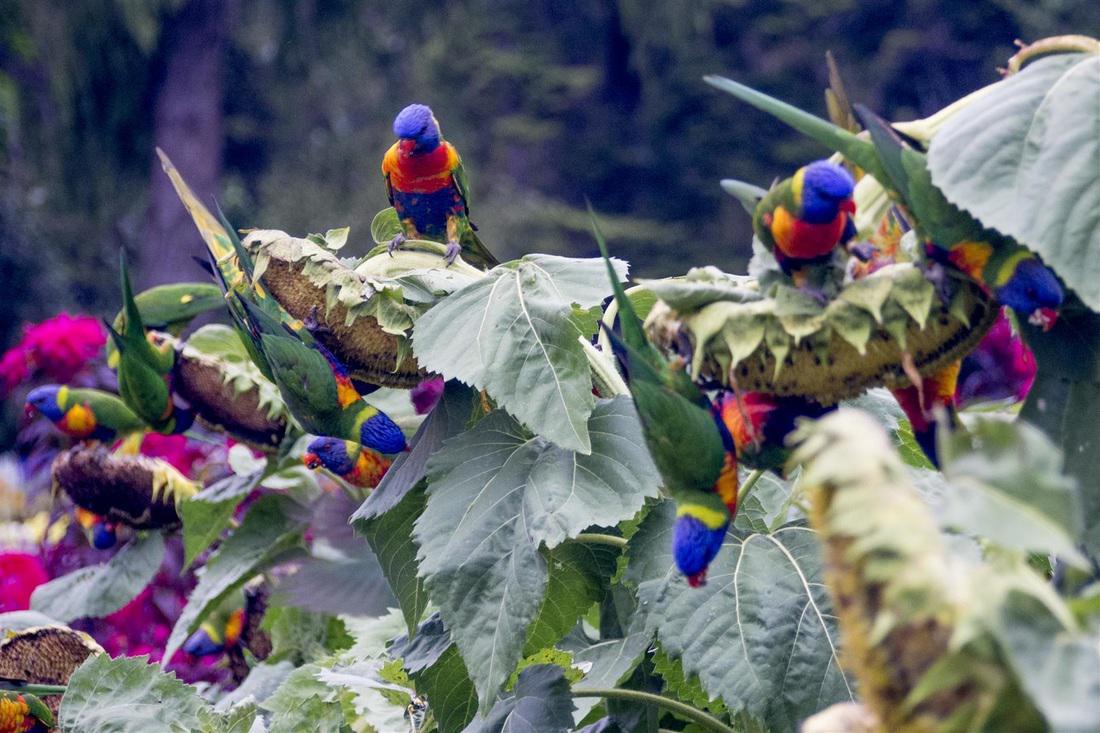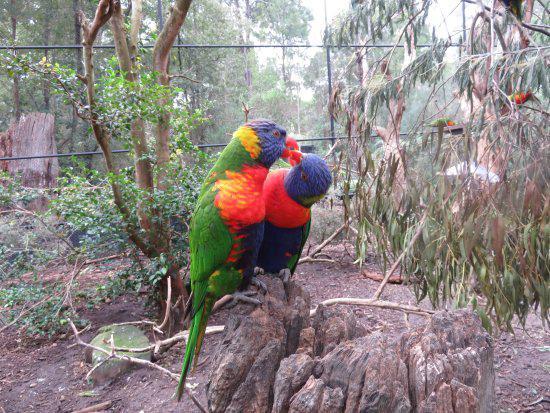The first image is the image on the left, the second image is the image on the right. Considering the images on both sides, is "Both pictures have an identical number of parrots perched on branches in the foreground." valid? Answer yes or no. No. The first image is the image on the left, the second image is the image on the right. For the images shown, is this caption "The image on the right contains two parrots." true? Answer yes or no. Yes. 